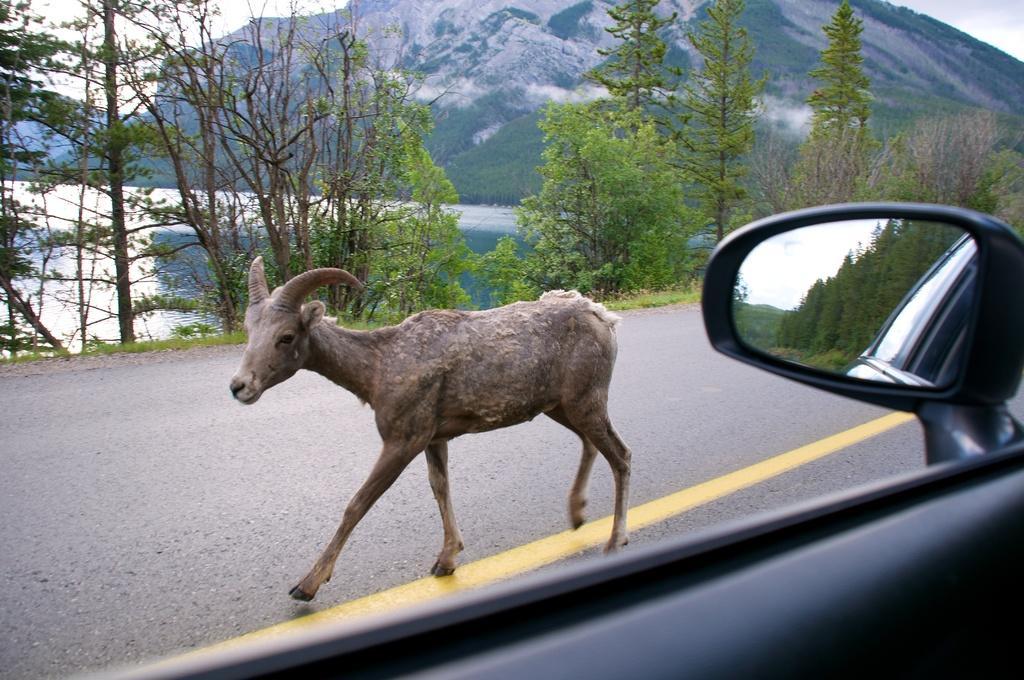In one or two sentences, can you explain what this image depicts? In the center of the image, we can see an animal on the road and there is a mirror to a vehicle. In the background, there are trees, hills and there is water. 